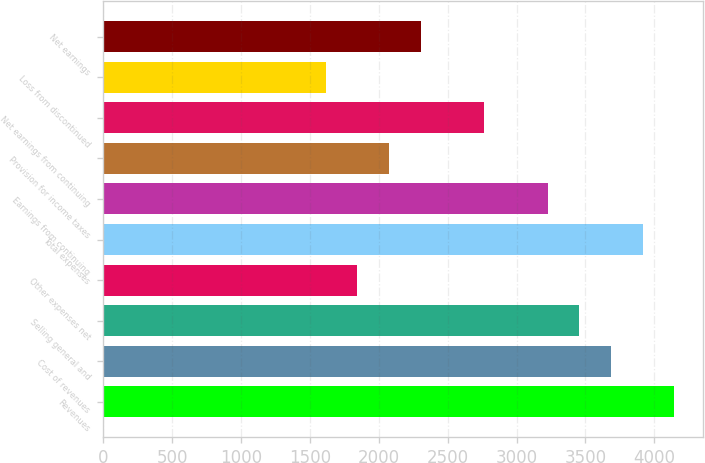Convert chart to OTSL. <chart><loc_0><loc_0><loc_500><loc_500><bar_chart><fcel>Revenues<fcel>Cost of revenues<fcel>Selling general and<fcel>Other expenses net<fcel>Total expenses<fcel>Earnings from continuing<fcel>Provision for income taxes<fcel>Net earnings from continuing<fcel>Loss from discontinued<fcel>Net earnings<nl><fcel>4146.31<fcel>3685.61<fcel>3455.26<fcel>1842.81<fcel>3915.96<fcel>3224.91<fcel>2073.16<fcel>2764.21<fcel>1612.46<fcel>2303.51<nl></chart> 